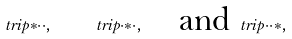<formula> <loc_0><loc_0><loc_500><loc_500>\ t r i p { \ast } { \cdot } { \cdot } , \quad \ t r i p { \cdot } { \ast } { \cdot } , \quad \text {and} \, \ t r i p { \cdot } { \cdot } { \ast } ,</formula> 